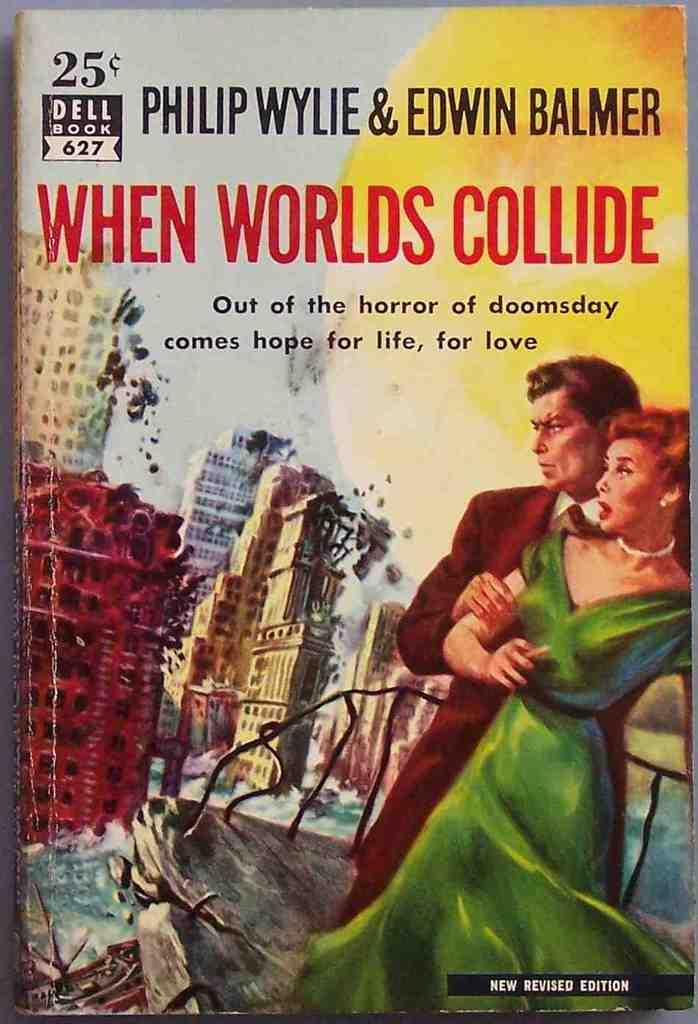<image>
Give a short and clear explanation of the subsequent image. The book, When worlds collide was priced at 25 cents 